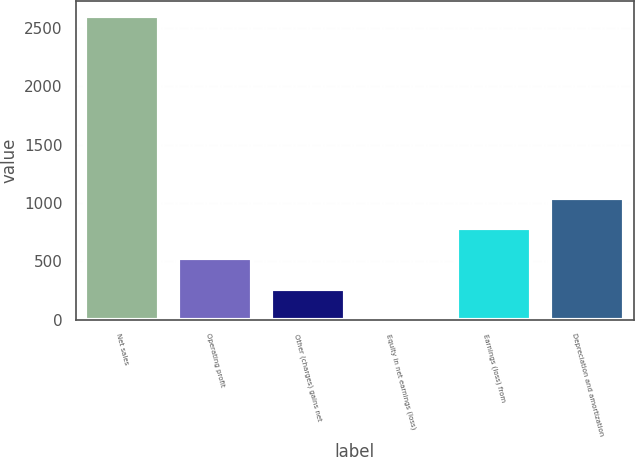Convert chart to OTSL. <chart><loc_0><loc_0><loc_500><loc_500><bar_chart><fcel>Net sales<fcel>Operating profit<fcel>Other (charges) gains net<fcel>Equity in net earnings (loss)<fcel>Earnings (loss) from<fcel>Depreciation and amortization<nl><fcel>2603<fcel>524.6<fcel>264.8<fcel>5<fcel>784.4<fcel>1044.2<nl></chart> 